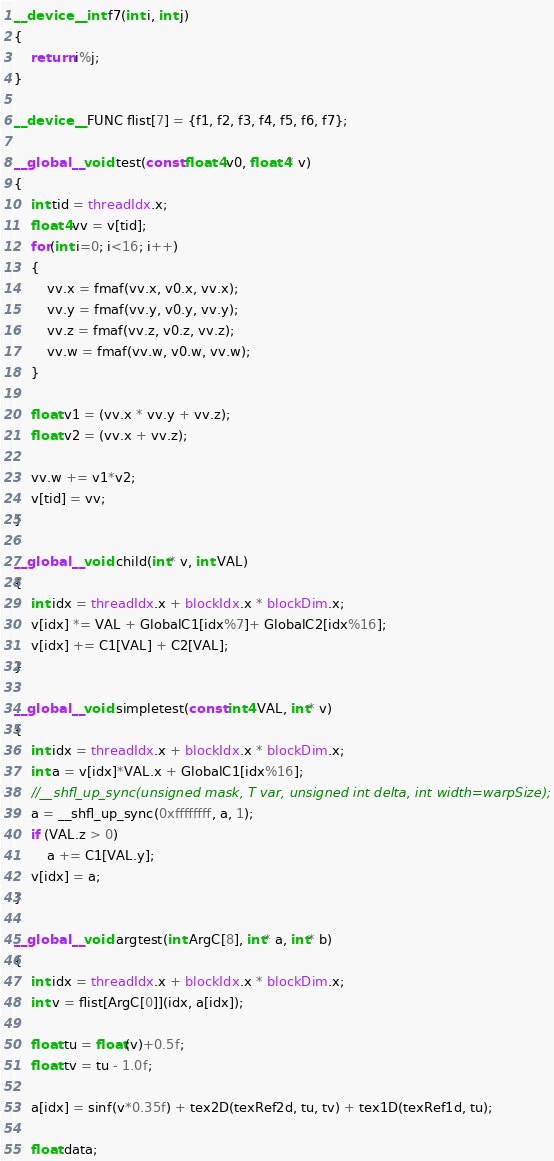Convert code to text. <code><loc_0><loc_0><loc_500><loc_500><_Cuda_>
__device__ int f7(int i, int j)
{
    return i%j;
}

__device__ FUNC flist[7] = {f1, f2, f3, f4, f5, f6, f7};

__global__ void test(const float4 v0, float4* v)
{
    int tid = threadIdx.x;
    float4 vv = v[tid];
    for(int i=0; i<16; i++)
    {
        vv.x = fmaf(vv.x, v0.x, vv.x);
        vv.y = fmaf(vv.y, v0.y, vv.y);
        vv.z = fmaf(vv.z, v0.z, vv.z);
        vv.w = fmaf(vv.w, v0.w, vv.w);
    }

    float v1 = (vv.x * vv.y + vv.z);
    float v2 = (vv.x + vv.z);
    
    vv.w += v1*v2;
    v[tid] = vv;
}

__global__ void child(int* v, int VAL)
{
    int idx = threadIdx.x + blockIdx.x * blockDim.x;
    v[idx] *= VAL + GlobalC1[idx%7]+ GlobalC2[idx%16];
    v[idx] += C1[VAL] + C2[VAL];
}

__global__ void simpletest(const int4 VAL, int* v)
{
    int idx = threadIdx.x + blockIdx.x * blockDim.x;
    int a = v[idx]*VAL.x + GlobalC1[idx%16];
    //__shfl_up_sync(unsigned mask, T var, unsigned int delta, int width=warpSize);
    a = __shfl_up_sync(0xffffffff, a, 1);
    if (VAL.z > 0)
        a += C1[VAL.y];
    v[idx] = a;
}

__global__ void argtest(int ArgC[8], int* a, int* b)
{
    int idx = threadIdx.x + blockIdx.x * blockDim.x;
    int v = flist[ArgC[0]](idx, a[idx]);

    float tu = float(v)+0.5f;
    float tv = tu - 1.0f;

    a[idx] = sinf(v*0.35f) + tex2D(texRef2d, tu, tv) + tex1D(texRef1d, tu);

    float data;</code> 